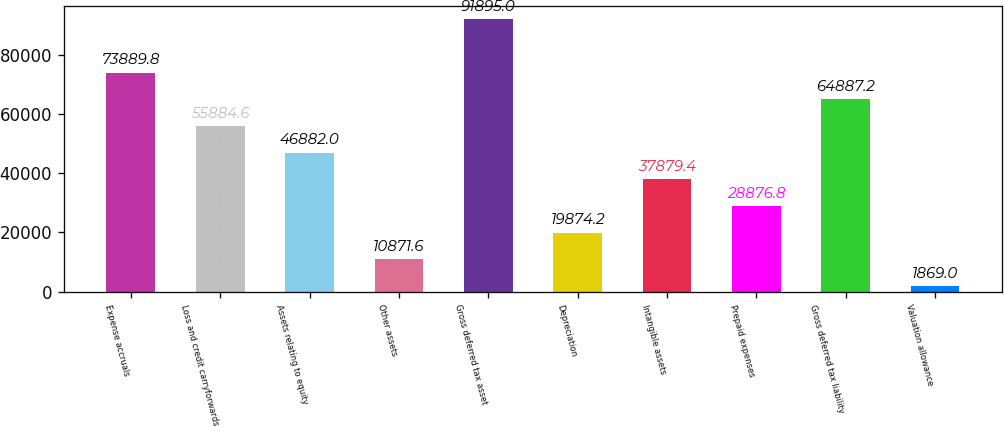Convert chart. <chart><loc_0><loc_0><loc_500><loc_500><bar_chart><fcel>Expense accruals<fcel>Loss and credit carryforwards<fcel>Assets relating to equity<fcel>Other assets<fcel>Gross deferred tax asset<fcel>Depreciation<fcel>Intangible assets<fcel>Prepaid expenses<fcel>Gross deferred tax liability<fcel>Valuation allowance<nl><fcel>73889.8<fcel>55884.6<fcel>46882<fcel>10871.6<fcel>91895<fcel>19874.2<fcel>37879.4<fcel>28876.8<fcel>64887.2<fcel>1869<nl></chart> 